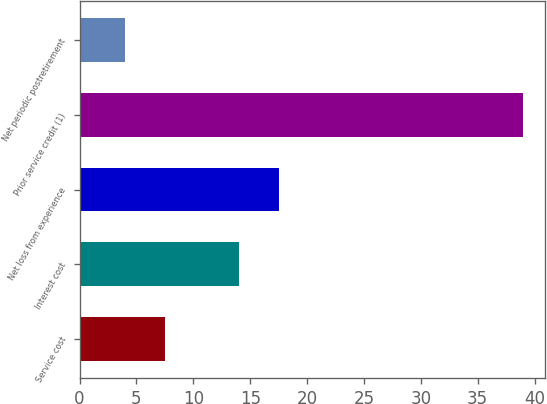Convert chart to OTSL. <chart><loc_0><loc_0><loc_500><loc_500><bar_chart><fcel>Service cost<fcel>Interest cost<fcel>Net loss from experience<fcel>Prior service credit (1)<fcel>Net periodic postretirement<nl><fcel>7.5<fcel>14<fcel>17.5<fcel>39<fcel>4<nl></chart> 